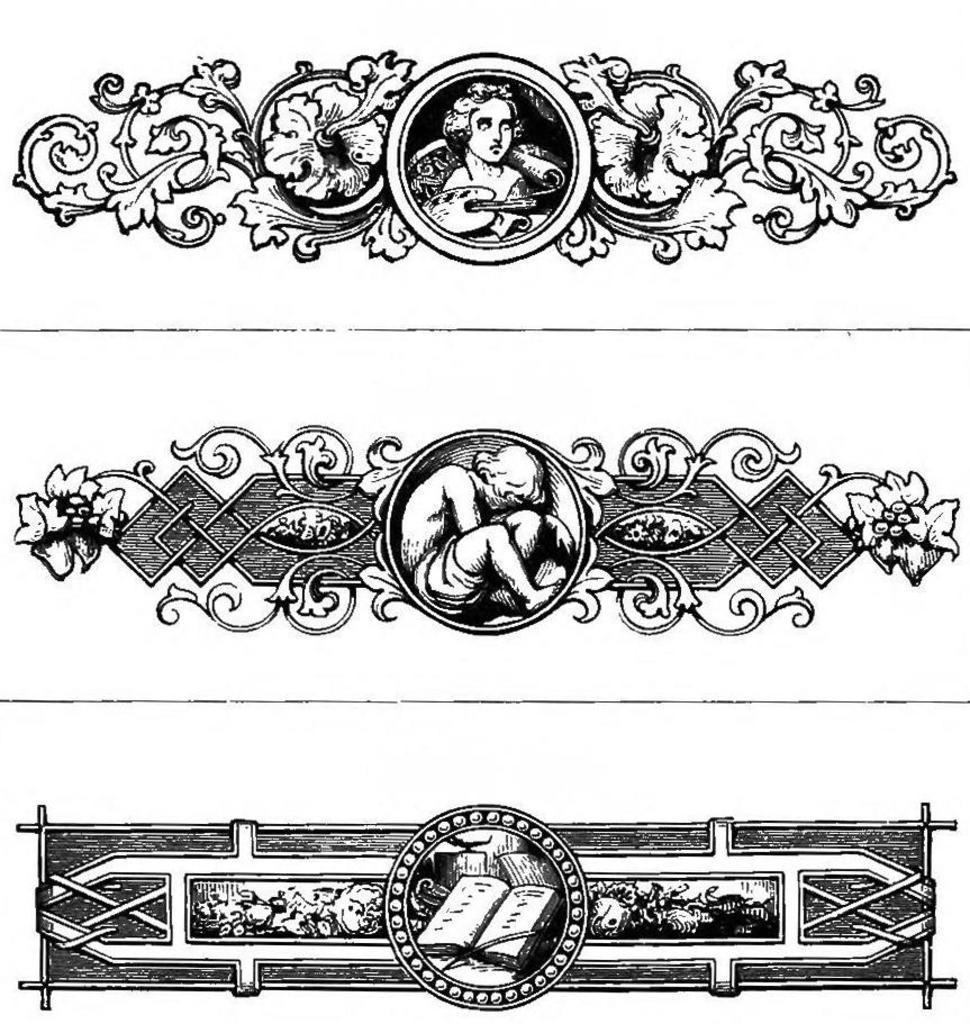How would you summarize this image in a sentence or two? In this picture I can see 3 different types of designs and I see that they're of black in color and I see that they're of white and black color. 